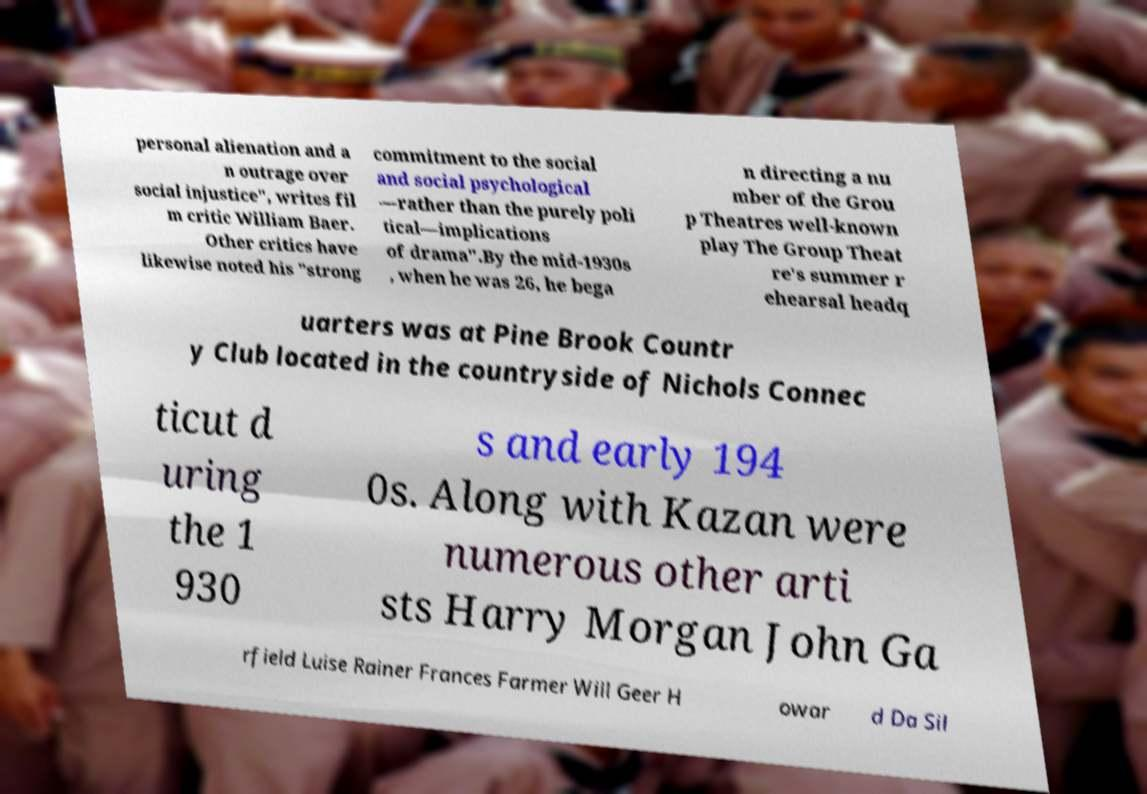There's text embedded in this image that I need extracted. Can you transcribe it verbatim? personal alienation and a n outrage over social injustice", writes fil m critic William Baer. Other critics have likewise noted his "strong commitment to the social and social psychological —rather than the purely poli tical—implications of drama".By the mid-1930s , when he was 26, he bega n directing a nu mber of the Grou p Theatres well-known play The Group Theat re's summer r ehearsal headq uarters was at Pine Brook Countr y Club located in the countryside of Nichols Connec ticut d uring the 1 930 s and early 194 0s. Along with Kazan were numerous other arti sts Harry Morgan John Ga rfield Luise Rainer Frances Farmer Will Geer H owar d Da Sil 